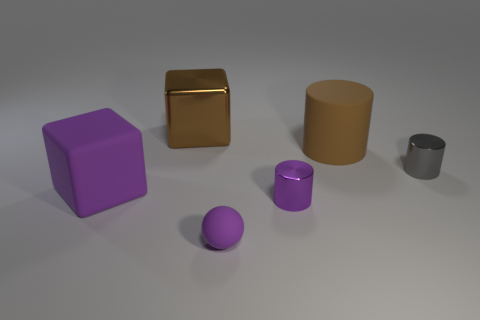Add 3 tiny matte balls. How many objects exist? 9 Subtract all blocks. How many objects are left? 4 Add 5 small cylinders. How many small cylinders are left? 7 Add 2 rubber cubes. How many rubber cubes exist? 3 Subtract 1 purple blocks. How many objects are left? 5 Subtract all purple rubber things. Subtract all tiny red rubber balls. How many objects are left? 4 